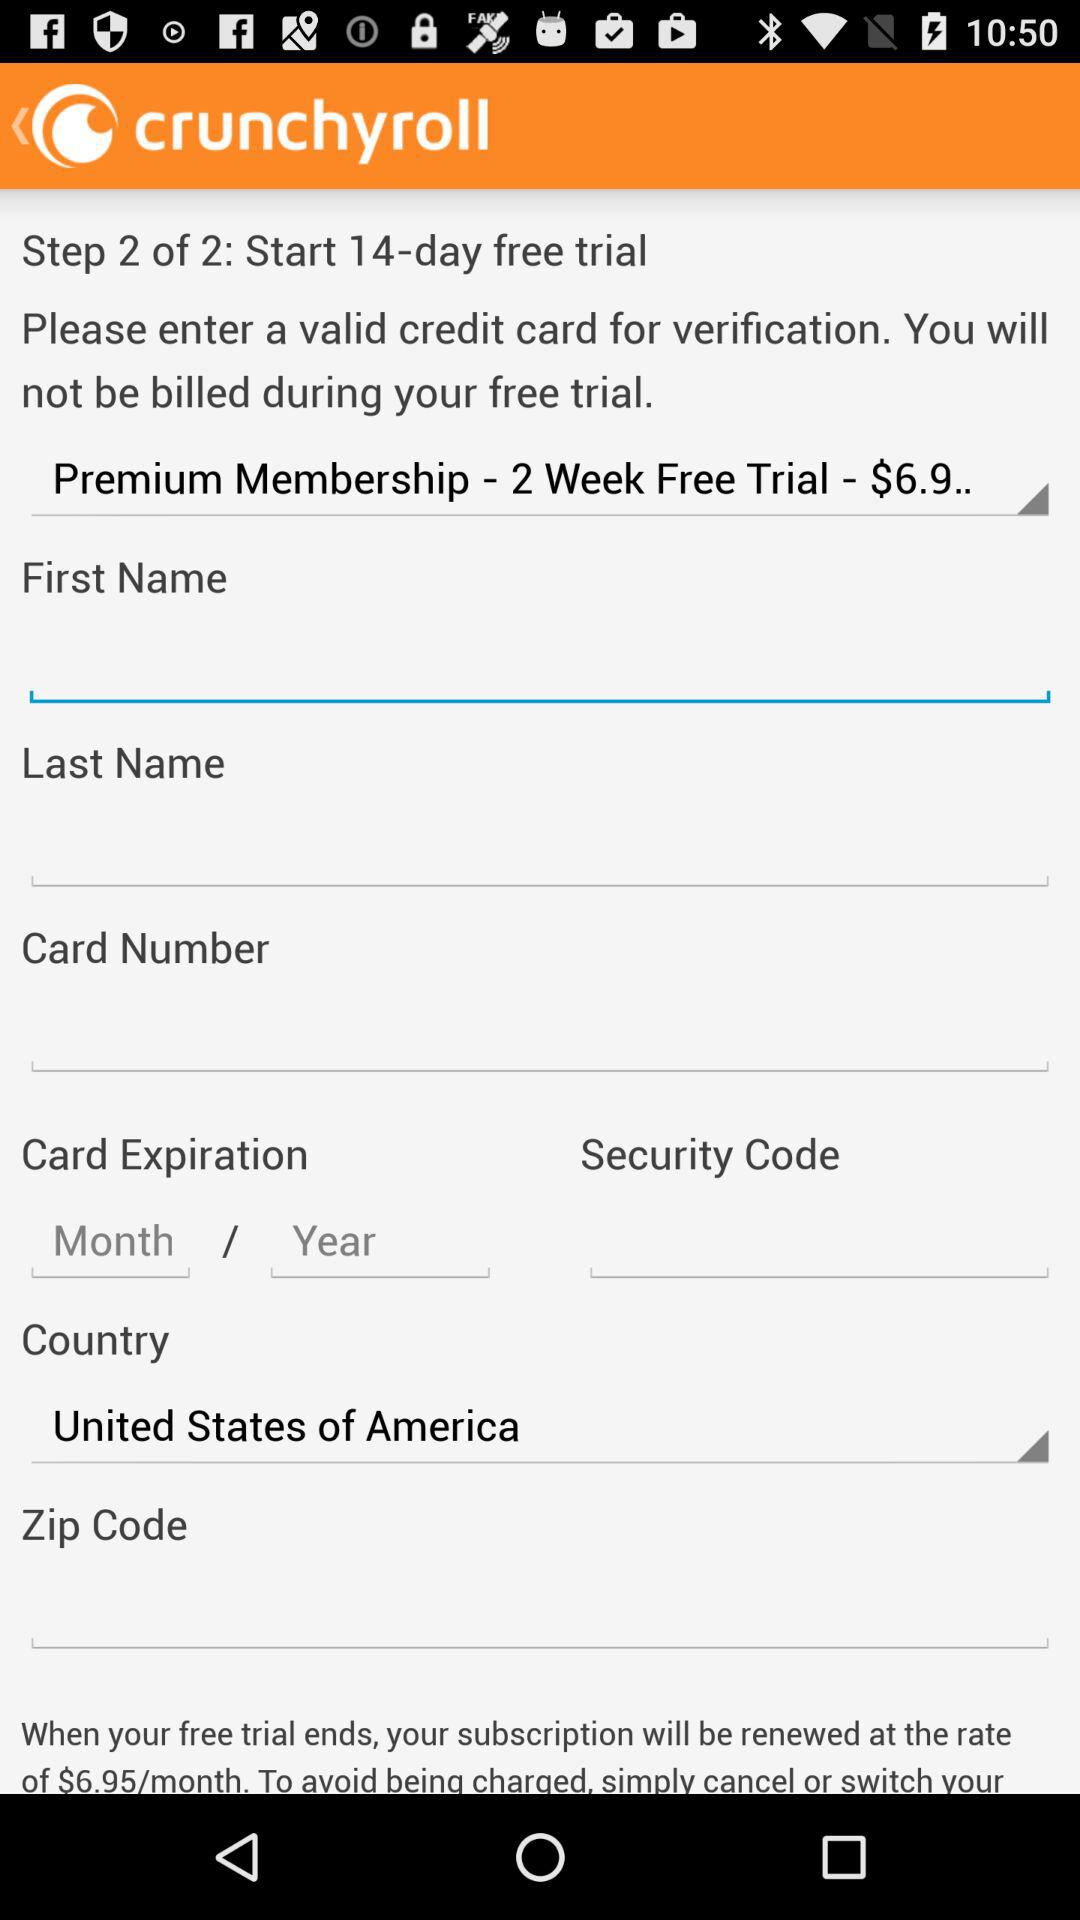How many days the free trial is for? It is for 14 days. 